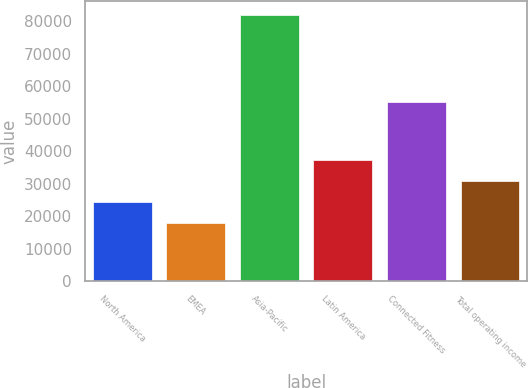Convert chart to OTSL. <chart><loc_0><loc_0><loc_500><loc_500><bar_chart><fcel>North America<fcel>EMEA<fcel>Asia-Pacific<fcel>Latin America<fcel>Connected Fitness<fcel>Total operating income<nl><fcel>24382.3<fcel>17976<fcel>82039<fcel>37194.9<fcel>55266<fcel>30788.6<nl></chart> 